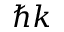<formula> <loc_0><loc_0><loc_500><loc_500>\hbar { k }</formula> 